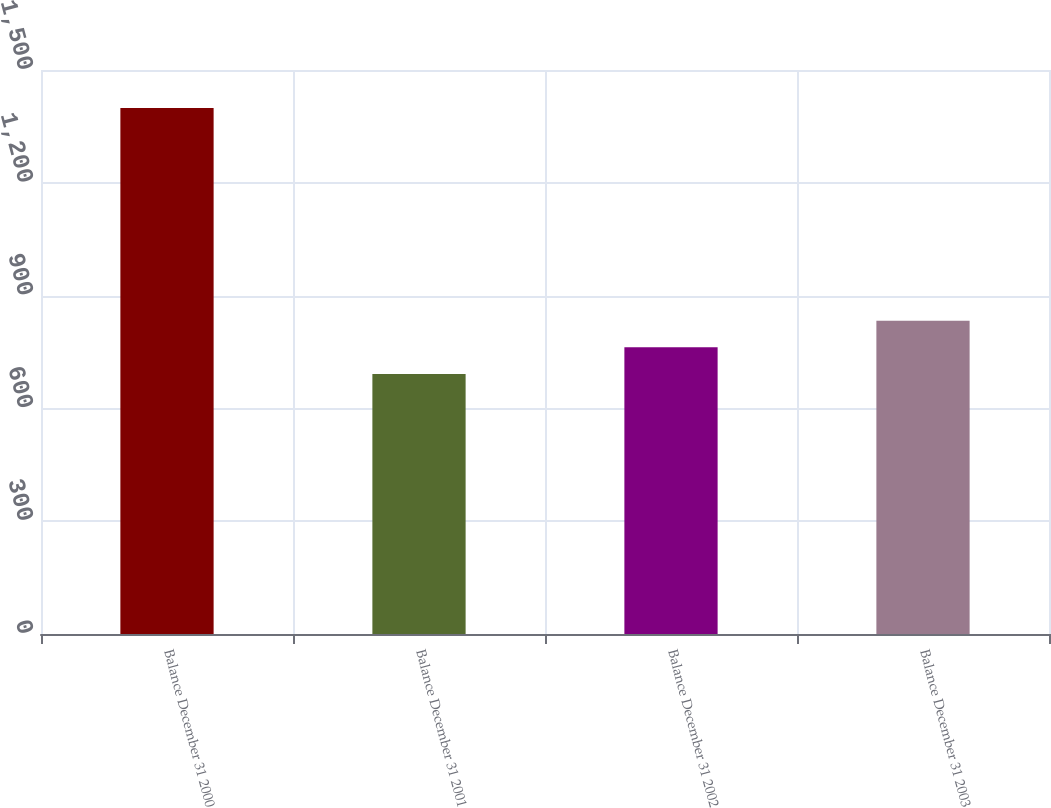Convert chart. <chart><loc_0><loc_0><loc_500><loc_500><bar_chart><fcel>Balance December 31 2000<fcel>Balance December 31 2001<fcel>Balance December 31 2002<fcel>Balance December 31 2003<nl><fcel>1398.9<fcel>691.8<fcel>762.51<fcel>833.22<nl></chart> 